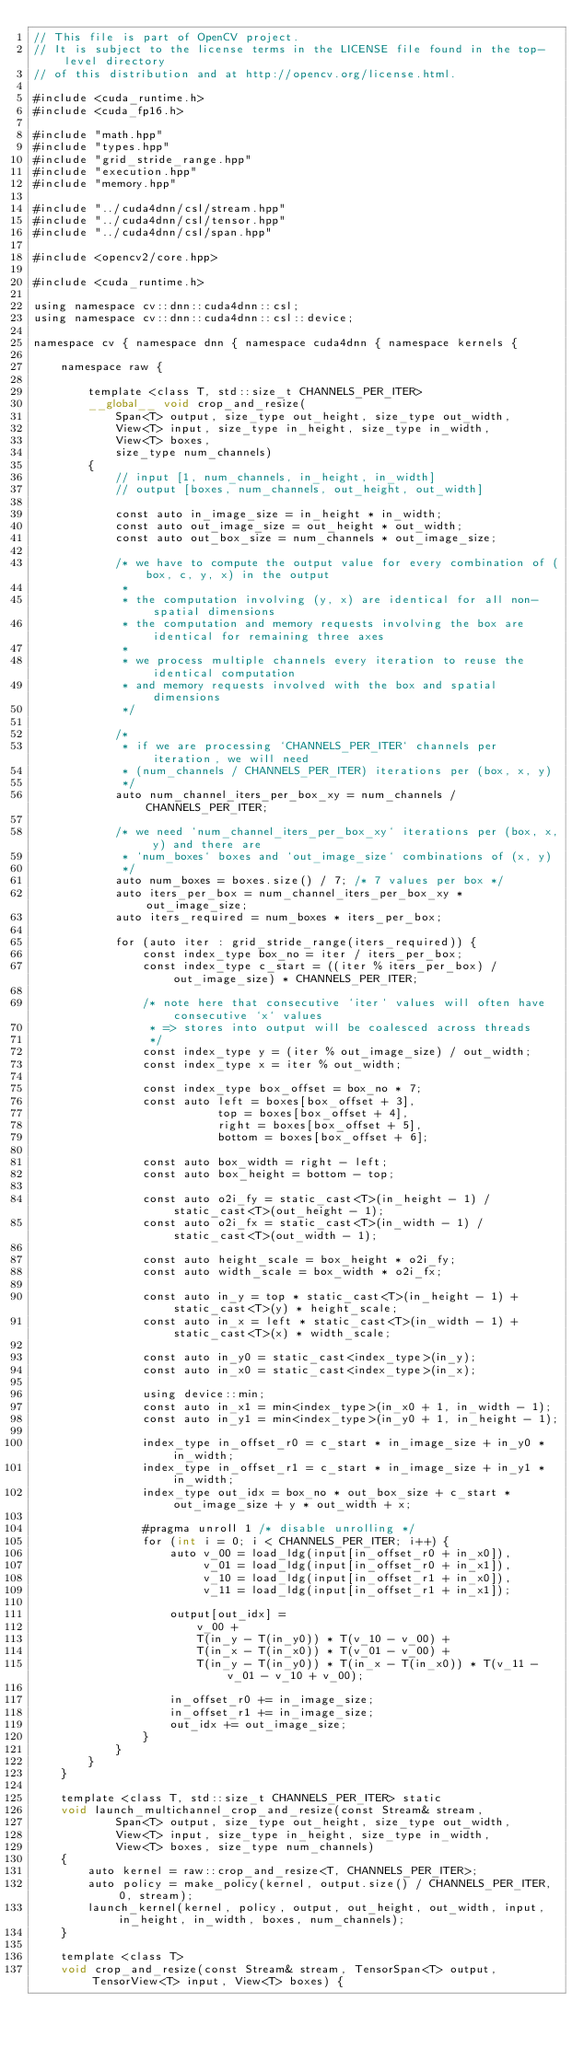<code> <loc_0><loc_0><loc_500><loc_500><_Cuda_>// This file is part of OpenCV project.
// It is subject to the license terms in the LICENSE file found in the top-level directory
// of this distribution and at http://opencv.org/license.html.

#include <cuda_runtime.h>
#include <cuda_fp16.h>

#include "math.hpp"
#include "types.hpp"
#include "grid_stride_range.hpp"
#include "execution.hpp"
#include "memory.hpp"

#include "../cuda4dnn/csl/stream.hpp"
#include "../cuda4dnn/csl/tensor.hpp"
#include "../cuda4dnn/csl/span.hpp"

#include <opencv2/core.hpp>

#include <cuda_runtime.h>

using namespace cv::dnn::cuda4dnn::csl;
using namespace cv::dnn::cuda4dnn::csl::device;

namespace cv { namespace dnn { namespace cuda4dnn { namespace kernels {

    namespace raw {

        template <class T, std::size_t CHANNELS_PER_ITER>
        __global__ void crop_and_resize(
            Span<T> output, size_type out_height, size_type out_width,
            View<T> input, size_type in_height, size_type in_width,
            View<T> boxes,
            size_type num_channels)
        {
            // input [1, num_channels, in_height, in_width]
            // output [boxes, num_channels, out_height, out_width]

            const auto in_image_size = in_height * in_width;
            const auto out_image_size = out_height * out_width;
            const auto out_box_size = num_channels * out_image_size;

            /* we have to compute the output value for every combination of (box, c, y, x) in the output
             *
             * the computation involving (y, x) are identical for all non-spatial dimensions
             * the computation and memory requests involving the box are identical for remaining three axes
             *
             * we process multiple channels every iteration to reuse the identical computation
             * and memory requests involved with the box and spatial dimensions
             */

            /*
             * if we are processing `CHANNELS_PER_ITER` channels per iteration, we will need
             * (num_channels / CHANNELS_PER_ITER) iterations per (box, x, y)
             */
            auto num_channel_iters_per_box_xy = num_channels / CHANNELS_PER_ITER;

            /* we need `num_channel_iters_per_box_xy` iterations per (box, x, y) and there are
             * `num_boxes` boxes and `out_image_size` combinations of (x, y)
             */
            auto num_boxes = boxes.size() / 7; /* 7 values per box */
            auto iters_per_box = num_channel_iters_per_box_xy * out_image_size;
            auto iters_required = num_boxes * iters_per_box;

            for (auto iter : grid_stride_range(iters_required)) {
                const index_type box_no = iter / iters_per_box;
                const index_type c_start = ((iter % iters_per_box) / out_image_size) * CHANNELS_PER_ITER;

                /* note here that consecutive `iter` values will often have consecutive `x` values
                 * => stores into output will be coalesced across threads
                 */
                const index_type y = (iter % out_image_size) / out_width;
                const index_type x = iter % out_width;

                const index_type box_offset = box_no * 7;
                const auto left = boxes[box_offset + 3],
                           top = boxes[box_offset + 4],
                           right = boxes[box_offset + 5],
                           bottom = boxes[box_offset + 6];

                const auto box_width = right - left;
                const auto box_height = bottom - top;

                const auto o2i_fy = static_cast<T>(in_height - 1) / static_cast<T>(out_height - 1);
                const auto o2i_fx = static_cast<T>(in_width - 1) / static_cast<T>(out_width - 1);

                const auto height_scale = box_height * o2i_fy;
                const auto width_scale = box_width * o2i_fx;

                const auto in_y = top * static_cast<T>(in_height - 1) + static_cast<T>(y) * height_scale;
                const auto in_x = left * static_cast<T>(in_width - 1) + static_cast<T>(x) * width_scale;

                const auto in_y0 = static_cast<index_type>(in_y);
                const auto in_x0 = static_cast<index_type>(in_x);

                using device::min;
                const auto in_x1 = min<index_type>(in_x0 + 1, in_width - 1);
                const auto in_y1 = min<index_type>(in_y0 + 1, in_height - 1);

                index_type in_offset_r0 = c_start * in_image_size + in_y0 * in_width;
                index_type in_offset_r1 = c_start * in_image_size + in_y1 * in_width;
                index_type out_idx = box_no * out_box_size + c_start * out_image_size + y * out_width + x;

                #pragma unroll 1 /* disable unrolling */
                for (int i = 0; i < CHANNELS_PER_ITER; i++) {
                    auto v_00 = load_ldg(input[in_offset_r0 + in_x0]),
                         v_01 = load_ldg(input[in_offset_r0 + in_x1]),
                         v_10 = load_ldg(input[in_offset_r1 + in_x0]),
                         v_11 = load_ldg(input[in_offset_r1 + in_x1]);

                    output[out_idx] =
                        v_00 +
                        T(in_y - T(in_y0)) * T(v_10 - v_00) +
                        T(in_x - T(in_x0)) * T(v_01 - v_00) +
                        T(in_y - T(in_y0)) * T(in_x - T(in_x0)) * T(v_11 - v_01 - v_10 + v_00);

                    in_offset_r0 += in_image_size;
                    in_offset_r1 += in_image_size;
                    out_idx += out_image_size;
                }
            }
        }
    }

    template <class T, std::size_t CHANNELS_PER_ITER> static
    void launch_multichannel_crop_and_resize(const Stream& stream,
            Span<T> output, size_type out_height, size_type out_width,
            View<T> input, size_type in_height, size_type in_width,
            View<T> boxes, size_type num_channels)
    {
        auto kernel = raw::crop_and_resize<T, CHANNELS_PER_ITER>;
        auto policy = make_policy(kernel, output.size() / CHANNELS_PER_ITER, 0, stream);
        launch_kernel(kernel, policy, output, out_height, out_width, input, in_height, in_width, boxes, num_channels);
    }

    template <class T>
    void crop_and_resize(const Stream& stream, TensorSpan<T> output, TensorView<T> input, View<T> boxes) {</code> 